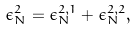Convert formula to latex. <formula><loc_0><loc_0><loc_500><loc_500>\epsilon _ { N } ^ { 2 } = \epsilon _ { N } ^ { 2 , 1 } + \epsilon _ { N } ^ { 2 , 2 } ,</formula> 